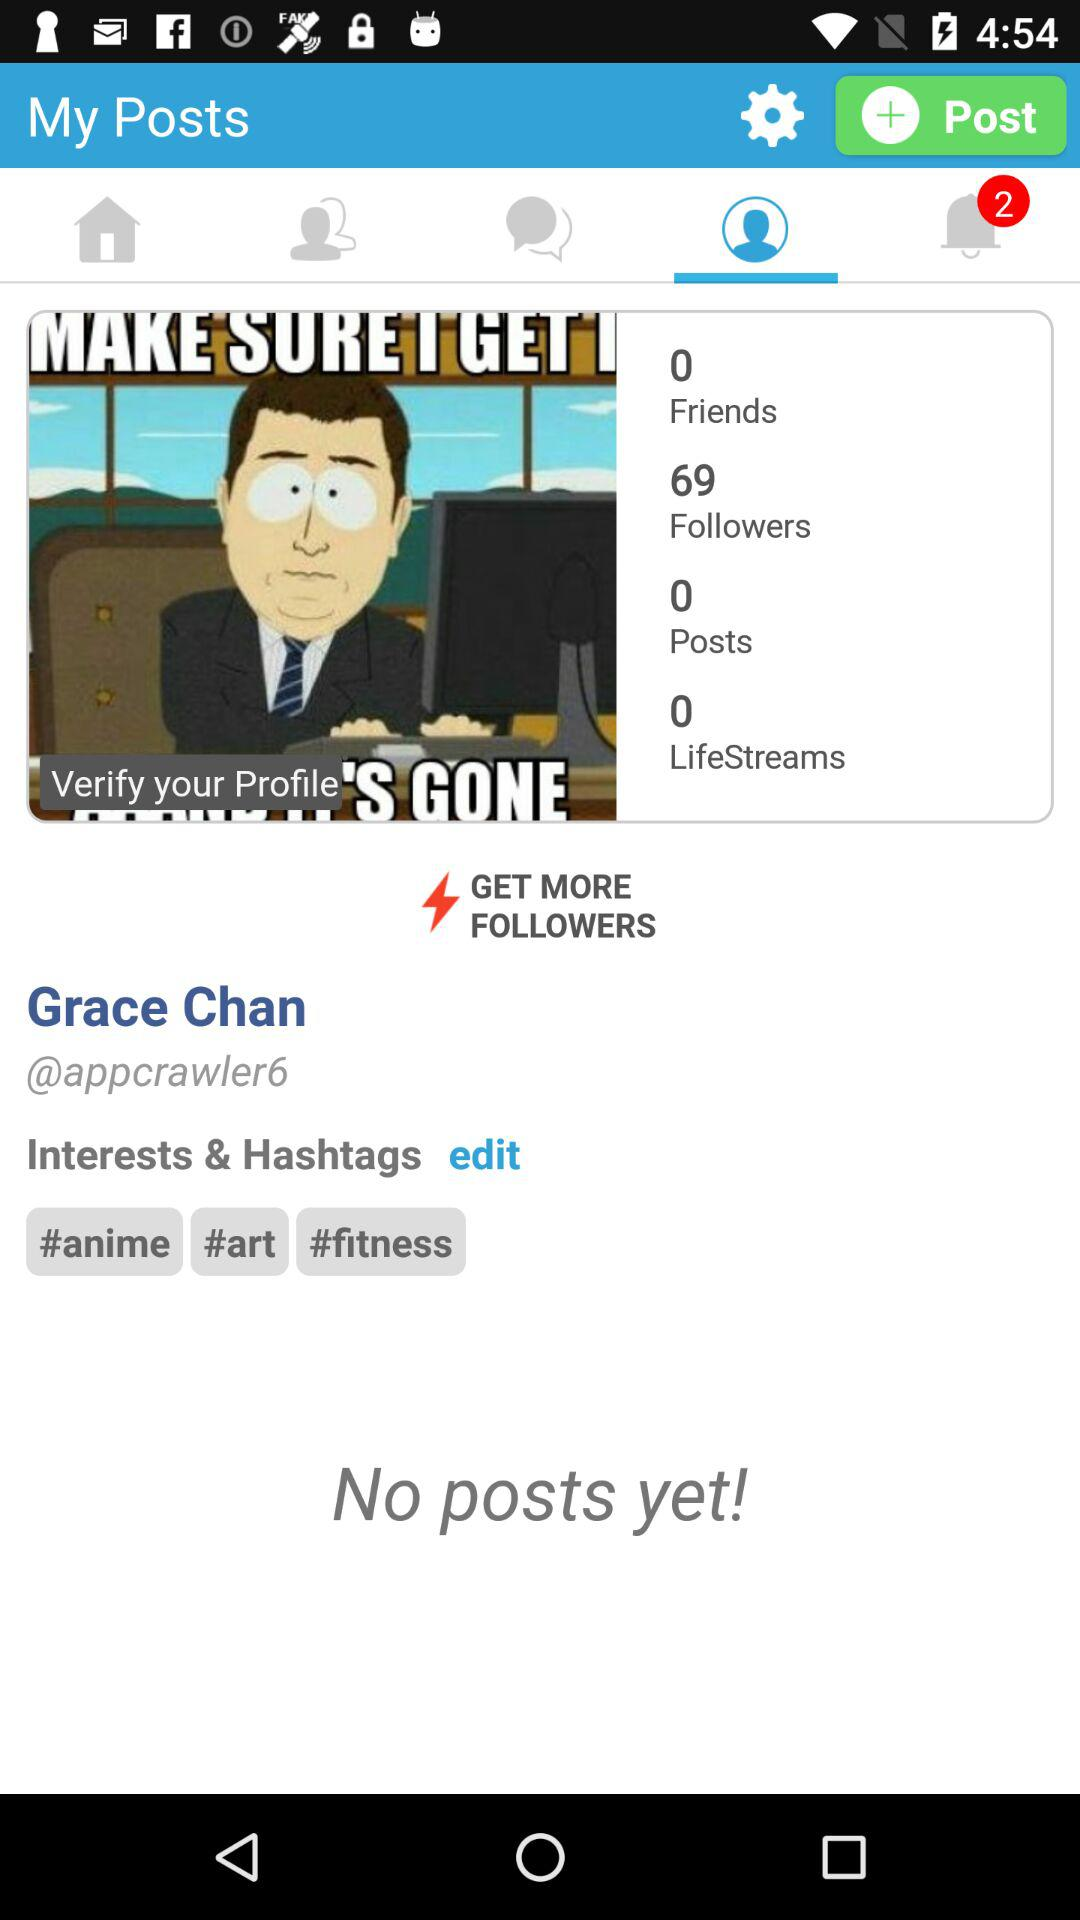How many lifestreams are there? There are 0 lifestreams. 